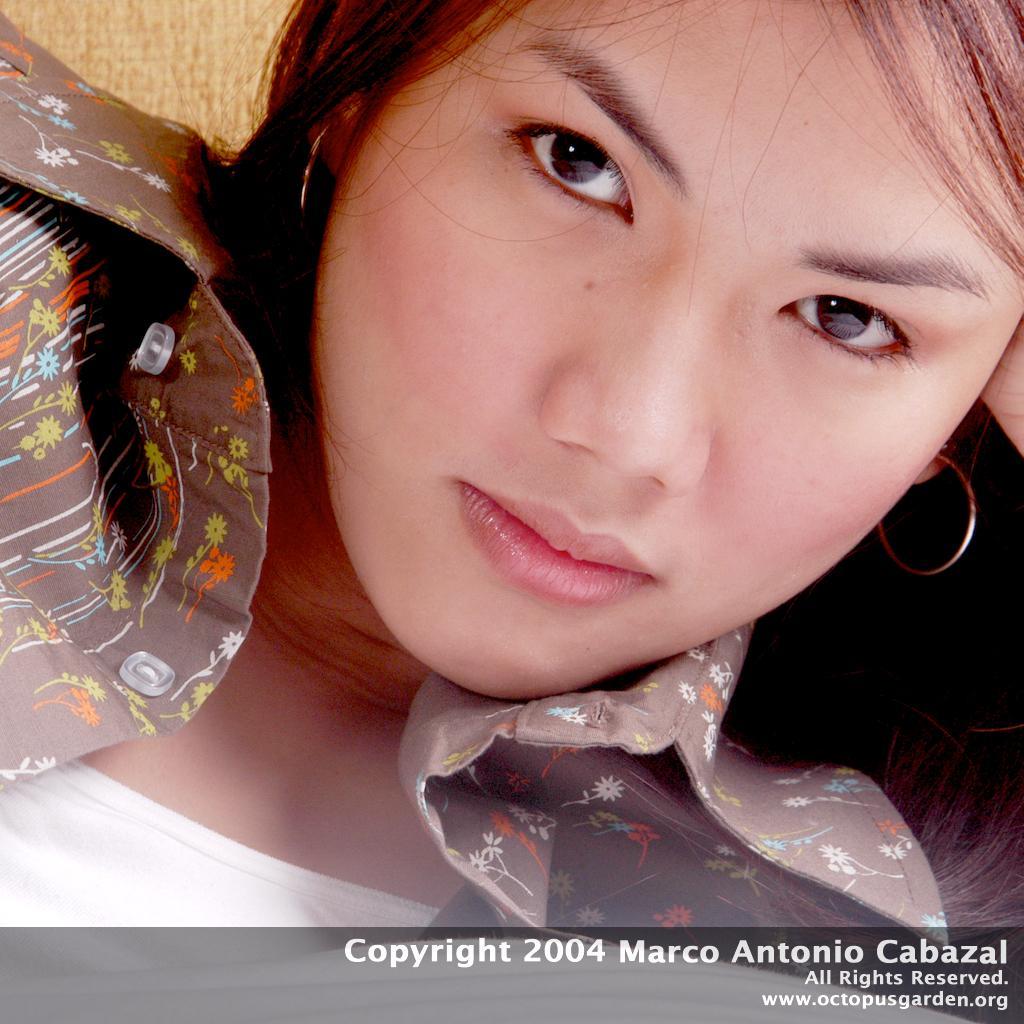In one or two sentences, can you explain what this image depicts? In the picture we can see a face of a woman with earrings and a shirt with some designs to it and inside with white T-shirt. 